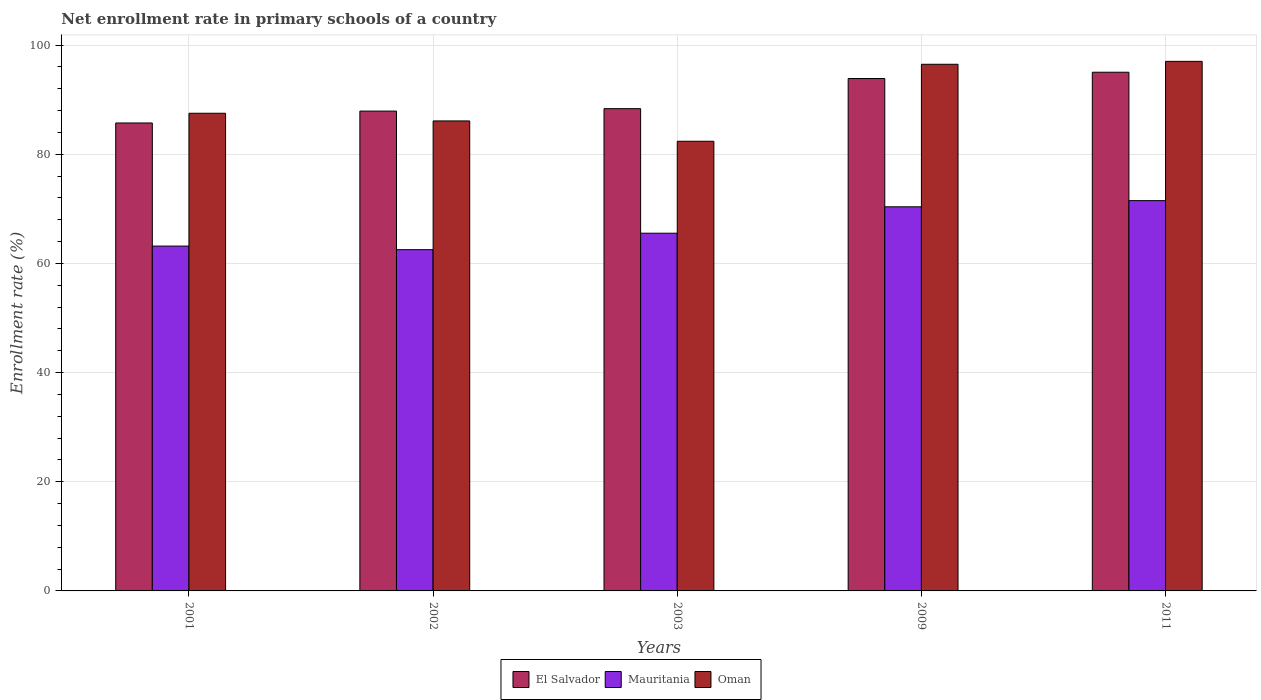How many groups of bars are there?
Your response must be concise. 5. Are the number of bars per tick equal to the number of legend labels?
Offer a very short reply. Yes. Are the number of bars on each tick of the X-axis equal?
Give a very brief answer. Yes. How many bars are there on the 1st tick from the left?
Your answer should be very brief. 3. What is the enrollment rate in primary schools in El Salvador in 2002?
Make the answer very short. 87.91. Across all years, what is the maximum enrollment rate in primary schools in Oman?
Provide a short and direct response. 97.03. Across all years, what is the minimum enrollment rate in primary schools in Mauritania?
Keep it short and to the point. 62.52. In which year was the enrollment rate in primary schools in Mauritania maximum?
Offer a terse response. 2011. What is the total enrollment rate in primary schools in El Salvador in the graph?
Keep it short and to the point. 450.93. What is the difference between the enrollment rate in primary schools in Oman in 2002 and that in 2011?
Provide a succinct answer. -10.91. What is the difference between the enrollment rate in primary schools in Mauritania in 2003 and the enrollment rate in primary schools in Oman in 2009?
Offer a very short reply. -30.95. What is the average enrollment rate in primary schools in Oman per year?
Your answer should be compact. 89.91. In the year 2002, what is the difference between the enrollment rate in primary schools in Oman and enrollment rate in primary schools in Mauritania?
Make the answer very short. 23.59. What is the ratio of the enrollment rate in primary schools in Mauritania in 2002 to that in 2003?
Keep it short and to the point. 0.95. Is the enrollment rate in primary schools in Mauritania in 2001 less than that in 2009?
Offer a terse response. Yes. What is the difference between the highest and the second highest enrollment rate in primary schools in Oman?
Offer a terse response. 0.54. What is the difference between the highest and the lowest enrollment rate in primary schools in El Salvador?
Make the answer very short. 9.3. In how many years, is the enrollment rate in primary schools in Mauritania greater than the average enrollment rate in primary schools in Mauritania taken over all years?
Your answer should be compact. 2. Is the sum of the enrollment rate in primary schools in Mauritania in 2003 and 2009 greater than the maximum enrollment rate in primary schools in El Salvador across all years?
Offer a very short reply. Yes. What does the 2nd bar from the left in 2003 represents?
Offer a very short reply. Mauritania. What does the 3rd bar from the right in 2001 represents?
Give a very brief answer. El Salvador. Is it the case that in every year, the sum of the enrollment rate in primary schools in El Salvador and enrollment rate in primary schools in Mauritania is greater than the enrollment rate in primary schools in Oman?
Make the answer very short. Yes. How many bars are there?
Make the answer very short. 15. Are all the bars in the graph horizontal?
Make the answer very short. No. Are the values on the major ticks of Y-axis written in scientific E-notation?
Your answer should be compact. No. Does the graph contain any zero values?
Offer a terse response. No. Does the graph contain grids?
Your answer should be very brief. Yes. Where does the legend appear in the graph?
Ensure brevity in your answer.  Bottom center. What is the title of the graph?
Your response must be concise. Net enrollment rate in primary schools of a country. Does "Afghanistan" appear as one of the legend labels in the graph?
Make the answer very short. No. What is the label or title of the Y-axis?
Your answer should be very brief. Enrollment rate (%). What is the Enrollment rate (%) of El Salvador in 2001?
Make the answer very short. 85.74. What is the Enrollment rate (%) of Mauritania in 2001?
Your answer should be compact. 63.18. What is the Enrollment rate (%) of Oman in 2001?
Ensure brevity in your answer.  87.52. What is the Enrollment rate (%) of El Salvador in 2002?
Provide a succinct answer. 87.91. What is the Enrollment rate (%) in Mauritania in 2002?
Provide a succinct answer. 62.52. What is the Enrollment rate (%) of Oman in 2002?
Ensure brevity in your answer.  86.11. What is the Enrollment rate (%) of El Salvador in 2003?
Ensure brevity in your answer.  88.36. What is the Enrollment rate (%) in Mauritania in 2003?
Your response must be concise. 65.54. What is the Enrollment rate (%) in Oman in 2003?
Your answer should be very brief. 82.39. What is the Enrollment rate (%) of El Salvador in 2009?
Your response must be concise. 93.88. What is the Enrollment rate (%) of Mauritania in 2009?
Keep it short and to the point. 70.38. What is the Enrollment rate (%) in Oman in 2009?
Provide a short and direct response. 96.49. What is the Enrollment rate (%) in El Salvador in 2011?
Ensure brevity in your answer.  95.03. What is the Enrollment rate (%) of Mauritania in 2011?
Your answer should be very brief. 71.51. What is the Enrollment rate (%) in Oman in 2011?
Keep it short and to the point. 97.03. Across all years, what is the maximum Enrollment rate (%) in El Salvador?
Your answer should be very brief. 95.03. Across all years, what is the maximum Enrollment rate (%) of Mauritania?
Provide a succinct answer. 71.51. Across all years, what is the maximum Enrollment rate (%) in Oman?
Provide a short and direct response. 97.03. Across all years, what is the minimum Enrollment rate (%) of El Salvador?
Your response must be concise. 85.74. Across all years, what is the minimum Enrollment rate (%) in Mauritania?
Ensure brevity in your answer.  62.52. Across all years, what is the minimum Enrollment rate (%) of Oman?
Your response must be concise. 82.39. What is the total Enrollment rate (%) of El Salvador in the graph?
Make the answer very short. 450.93. What is the total Enrollment rate (%) of Mauritania in the graph?
Keep it short and to the point. 333.14. What is the total Enrollment rate (%) in Oman in the graph?
Make the answer very short. 449.54. What is the difference between the Enrollment rate (%) in El Salvador in 2001 and that in 2002?
Offer a very short reply. -2.18. What is the difference between the Enrollment rate (%) in Mauritania in 2001 and that in 2002?
Provide a succinct answer. 0.66. What is the difference between the Enrollment rate (%) in Oman in 2001 and that in 2002?
Ensure brevity in your answer.  1.41. What is the difference between the Enrollment rate (%) in El Salvador in 2001 and that in 2003?
Provide a short and direct response. -2.62. What is the difference between the Enrollment rate (%) of Mauritania in 2001 and that in 2003?
Offer a very short reply. -2.35. What is the difference between the Enrollment rate (%) of Oman in 2001 and that in 2003?
Ensure brevity in your answer.  5.13. What is the difference between the Enrollment rate (%) in El Salvador in 2001 and that in 2009?
Keep it short and to the point. -8.14. What is the difference between the Enrollment rate (%) of Mauritania in 2001 and that in 2009?
Your response must be concise. -7.19. What is the difference between the Enrollment rate (%) in Oman in 2001 and that in 2009?
Your answer should be very brief. -8.97. What is the difference between the Enrollment rate (%) in El Salvador in 2001 and that in 2011?
Your response must be concise. -9.3. What is the difference between the Enrollment rate (%) in Mauritania in 2001 and that in 2011?
Your answer should be very brief. -8.33. What is the difference between the Enrollment rate (%) in Oman in 2001 and that in 2011?
Give a very brief answer. -9.51. What is the difference between the Enrollment rate (%) of El Salvador in 2002 and that in 2003?
Ensure brevity in your answer.  -0.44. What is the difference between the Enrollment rate (%) of Mauritania in 2002 and that in 2003?
Your answer should be compact. -3.01. What is the difference between the Enrollment rate (%) of Oman in 2002 and that in 2003?
Offer a very short reply. 3.73. What is the difference between the Enrollment rate (%) in El Salvador in 2002 and that in 2009?
Offer a very short reply. -5.97. What is the difference between the Enrollment rate (%) in Mauritania in 2002 and that in 2009?
Provide a succinct answer. -7.85. What is the difference between the Enrollment rate (%) in Oman in 2002 and that in 2009?
Ensure brevity in your answer.  -10.38. What is the difference between the Enrollment rate (%) of El Salvador in 2002 and that in 2011?
Offer a terse response. -7.12. What is the difference between the Enrollment rate (%) in Mauritania in 2002 and that in 2011?
Give a very brief answer. -8.98. What is the difference between the Enrollment rate (%) in Oman in 2002 and that in 2011?
Give a very brief answer. -10.91. What is the difference between the Enrollment rate (%) in El Salvador in 2003 and that in 2009?
Offer a very short reply. -5.52. What is the difference between the Enrollment rate (%) of Mauritania in 2003 and that in 2009?
Your answer should be compact. -4.84. What is the difference between the Enrollment rate (%) of Oman in 2003 and that in 2009?
Offer a very short reply. -14.1. What is the difference between the Enrollment rate (%) in El Salvador in 2003 and that in 2011?
Ensure brevity in your answer.  -6.68. What is the difference between the Enrollment rate (%) in Mauritania in 2003 and that in 2011?
Provide a short and direct response. -5.97. What is the difference between the Enrollment rate (%) in Oman in 2003 and that in 2011?
Offer a terse response. -14.64. What is the difference between the Enrollment rate (%) in El Salvador in 2009 and that in 2011?
Your answer should be very brief. -1.15. What is the difference between the Enrollment rate (%) in Mauritania in 2009 and that in 2011?
Give a very brief answer. -1.13. What is the difference between the Enrollment rate (%) in Oman in 2009 and that in 2011?
Make the answer very short. -0.54. What is the difference between the Enrollment rate (%) of El Salvador in 2001 and the Enrollment rate (%) of Mauritania in 2002?
Offer a very short reply. 23.21. What is the difference between the Enrollment rate (%) in El Salvador in 2001 and the Enrollment rate (%) in Oman in 2002?
Your response must be concise. -0.37. What is the difference between the Enrollment rate (%) in Mauritania in 2001 and the Enrollment rate (%) in Oman in 2002?
Make the answer very short. -22.93. What is the difference between the Enrollment rate (%) in El Salvador in 2001 and the Enrollment rate (%) in Mauritania in 2003?
Provide a short and direct response. 20.2. What is the difference between the Enrollment rate (%) of El Salvador in 2001 and the Enrollment rate (%) of Oman in 2003?
Your response must be concise. 3.35. What is the difference between the Enrollment rate (%) in Mauritania in 2001 and the Enrollment rate (%) in Oman in 2003?
Your response must be concise. -19.2. What is the difference between the Enrollment rate (%) of El Salvador in 2001 and the Enrollment rate (%) of Mauritania in 2009?
Make the answer very short. 15.36. What is the difference between the Enrollment rate (%) of El Salvador in 2001 and the Enrollment rate (%) of Oman in 2009?
Keep it short and to the point. -10.75. What is the difference between the Enrollment rate (%) in Mauritania in 2001 and the Enrollment rate (%) in Oman in 2009?
Provide a succinct answer. -33.31. What is the difference between the Enrollment rate (%) in El Salvador in 2001 and the Enrollment rate (%) in Mauritania in 2011?
Give a very brief answer. 14.23. What is the difference between the Enrollment rate (%) of El Salvador in 2001 and the Enrollment rate (%) of Oman in 2011?
Offer a very short reply. -11.29. What is the difference between the Enrollment rate (%) in Mauritania in 2001 and the Enrollment rate (%) in Oman in 2011?
Your answer should be very brief. -33.84. What is the difference between the Enrollment rate (%) of El Salvador in 2002 and the Enrollment rate (%) of Mauritania in 2003?
Your response must be concise. 22.38. What is the difference between the Enrollment rate (%) in El Salvador in 2002 and the Enrollment rate (%) in Oman in 2003?
Provide a short and direct response. 5.53. What is the difference between the Enrollment rate (%) in Mauritania in 2002 and the Enrollment rate (%) in Oman in 2003?
Ensure brevity in your answer.  -19.86. What is the difference between the Enrollment rate (%) of El Salvador in 2002 and the Enrollment rate (%) of Mauritania in 2009?
Your answer should be very brief. 17.54. What is the difference between the Enrollment rate (%) in El Salvador in 2002 and the Enrollment rate (%) in Oman in 2009?
Your answer should be very brief. -8.58. What is the difference between the Enrollment rate (%) in Mauritania in 2002 and the Enrollment rate (%) in Oman in 2009?
Keep it short and to the point. -33.97. What is the difference between the Enrollment rate (%) of El Salvador in 2002 and the Enrollment rate (%) of Mauritania in 2011?
Make the answer very short. 16.4. What is the difference between the Enrollment rate (%) of El Salvador in 2002 and the Enrollment rate (%) of Oman in 2011?
Keep it short and to the point. -9.11. What is the difference between the Enrollment rate (%) in Mauritania in 2002 and the Enrollment rate (%) in Oman in 2011?
Provide a succinct answer. -34.5. What is the difference between the Enrollment rate (%) in El Salvador in 2003 and the Enrollment rate (%) in Mauritania in 2009?
Make the answer very short. 17.98. What is the difference between the Enrollment rate (%) in El Salvador in 2003 and the Enrollment rate (%) in Oman in 2009?
Your response must be concise. -8.13. What is the difference between the Enrollment rate (%) of Mauritania in 2003 and the Enrollment rate (%) of Oman in 2009?
Offer a terse response. -30.95. What is the difference between the Enrollment rate (%) of El Salvador in 2003 and the Enrollment rate (%) of Mauritania in 2011?
Offer a terse response. 16.85. What is the difference between the Enrollment rate (%) in El Salvador in 2003 and the Enrollment rate (%) in Oman in 2011?
Make the answer very short. -8.67. What is the difference between the Enrollment rate (%) in Mauritania in 2003 and the Enrollment rate (%) in Oman in 2011?
Provide a short and direct response. -31.49. What is the difference between the Enrollment rate (%) of El Salvador in 2009 and the Enrollment rate (%) of Mauritania in 2011?
Provide a succinct answer. 22.37. What is the difference between the Enrollment rate (%) in El Salvador in 2009 and the Enrollment rate (%) in Oman in 2011?
Keep it short and to the point. -3.15. What is the difference between the Enrollment rate (%) of Mauritania in 2009 and the Enrollment rate (%) of Oman in 2011?
Your answer should be compact. -26.65. What is the average Enrollment rate (%) in El Salvador per year?
Keep it short and to the point. 90.19. What is the average Enrollment rate (%) in Mauritania per year?
Give a very brief answer. 66.63. What is the average Enrollment rate (%) of Oman per year?
Your answer should be very brief. 89.91. In the year 2001, what is the difference between the Enrollment rate (%) in El Salvador and Enrollment rate (%) in Mauritania?
Your response must be concise. 22.55. In the year 2001, what is the difference between the Enrollment rate (%) in El Salvador and Enrollment rate (%) in Oman?
Make the answer very short. -1.78. In the year 2001, what is the difference between the Enrollment rate (%) of Mauritania and Enrollment rate (%) of Oman?
Your answer should be compact. -24.33. In the year 2002, what is the difference between the Enrollment rate (%) of El Salvador and Enrollment rate (%) of Mauritania?
Keep it short and to the point. 25.39. In the year 2002, what is the difference between the Enrollment rate (%) of El Salvador and Enrollment rate (%) of Oman?
Provide a succinct answer. 1.8. In the year 2002, what is the difference between the Enrollment rate (%) in Mauritania and Enrollment rate (%) in Oman?
Make the answer very short. -23.59. In the year 2003, what is the difference between the Enrollment rate (%) in El Salvador and Enrollment rate (%) in Mauritania?
Your response must be concise. 22.82. In the year 2003, what is the difference between the Enrollment rate (%) in El Salvador and Enrollment rate (%) in Oman?
Offer a terse response. 5.97. In the year 2003, what is the difference between the Enrollment rate (%) in Mauritania and Enrollment rate (%) in Oman?
Offer a terse response. -16.85. In the year 2009, what is the difference between the Enrollment rate (%) of El Salvador and Enrollment rate (%) of Mauritania?
Keep it short and to the point. 23.5. In the year 2009, what is the difference between the Enrollment rate (%) in El Salvador and Enrollment rate (%) in Oman?
Ensure brevity in your answer.  -2.61. In the year 2009, what is the difference between the Enrollment rate (%) of Mauritania and Enrollment rate (%) of Oman?
Make the answer very short. -26.11. In the year 2011, what is the difference between the Enrollment rate (%) of El Salvador and Enrollment rate (%) of Mauritania?
Make the answer very short. 23.52. In the year 2011, what is the difference between the Enrollment rate (%) of El Salvador and Enrollment rate (%) of Oman?
Ensure brevity in your answer.  -1.99. In the year 2011, what is the difference between the Enrollment rate (%) of Mauritania and Enrollment rate (%) of Oman?
Your response must be concise. -25.52. What is the ratio of the Enrollment rate (%) of El Salvador in 2001 to that in 2002?
Keep it short and to the point. 0.98. What is the ratio of the Enrollment rate (%) of Mauritania in 2001 to that in 2002?
Your answer should be compact. 1.01. What is the ratio of the Enrollment rate (%) in Oman in 2001 to that in 2002?
Give a very brief answer. 1.02. What is the ratio of the Enrollment rate (%) in El Salvador in 2001 to that in 2003?
Your answer should be very brief. 0.97. What is the ratio of the Enrollment rate (%) in Mauritania in 2001 to that in 2003?
Make the answer very short. 0.96. What is the ratio of the Enrollment rate (%) of Oman in 2001 to that in 2003?
Make the answer very short. 1.06. What is the ratio of the Enrollment rate (%) of El Salvador in 2001 to that in 2009?
Give a very brief answer. 0.91. What is the ratio of the Enrollment rate (%) in Mauritania in 2001 to that in 2009?
Make the answer very short. 0.9. What is the ratio of the Enrollment rate (%) in Oman in 2001 to that in 2009?
Ensure brevity in your answer.  0.91. What is the ratio of the Enrollment rate (%) in El Salvador in 2001 to that in 2011?
Keep it short and to the point. 0.9. What is the ratio of the Enrollment rate (%) of Mauritania in 2001 to that in 2011?
Your answer should be compact. 0.88. What is the ratio of the Enrollment rate (%) of Oman in 2001 to that in 2011?
Your response must be concise. 0.9. What is the ratio of the Enrollment rate (%) of Mauritania in 2002 to that in 2003?
Keep it short and to the point. 0.95. What is the ratio of the Enrollment rate (%) in Oman in 2002 to that in 2003?
Your answer should be compact. 1.05. What is the ratio of the Enrollment rate (%) of El Salvador in 2002 to that in 2009?
Give a very brief answer. 0.94. What is the ratio of the Enrollment rate (%) in Mauritania in 2002 to that in 2009?
Provide a succinct answer. 0.89. What is the ratio of the Enrollment rate (%) of Oman in 2002 to that in 2009?
Ensure brevity in your answer.  0.89. What is the ratio of the Enrollment rate (%) of El Salvador in 2002 to that in 2011?
Offer a terse response. 0.93. What is the ratio of the Enrollment rate (%) in Mauritania in 2002 to that in 2011?
Ensure brevity in your answer.  0.87. What is the ratio of the Enrollment rate (%) in Oman in 2002 to that in 2011?
Provide a succinct answer. 0.89. What is the ratio of the Enrollment rate (%) in Mauritania in 2003 to that in 2009?
Your answer should be compact. 0.93. What is the ratio of the Enrollment rate (%) in Oman in 2003 to that in 2009?
Your response must be concise. 0.85. What is the ratio of the Enrollment rate (%) in El Salvador in 2003 to that in 2011?
Keep it short and to the point. 0.93. What is the ratio of the Enrollment rate (%) in Mauritania in 2003 to that in 2011?
Ensure brevity in your answer.  0.92. What is the ratio of the Enrollment rate (%) of Oman in 2003 to that in 2011?
Provide a short and direct response. 0.85. What is the ratio of the Enrollment rate (%) in El Salvador in 2009 to that in 2011?
Your answer should be very brief. 0.99. What is the ratio of the Enrollment rate (%) of Mauritania in 2009 to that in 2011?
Your answer should be very brief. 0.98. What is the ratio of the Enrollment rate (%) of Oman in 2009 to that in 2011?
Your response must be concise. 0.99. What is the difference between the highest and the second highest Enrollment rate (%) in El Salvador?
Provide a short and direct response. 1.15. What is the difference between the highest and the second highest Enrollment rate (%) in Mauritania?
Your answer should be compact. 1.13. What is the difference between the highest and the second highest Enrollment rate (%) in Oman?
Offer a terse response. 0.54. What is the difference between the highest and the lowest Enrollment rate (%) of El Salvador?
Give a very brief answer. 9.3. What is the difference between the highest and the lowest Enrollment rate (%) in Mauritania?
Your answer should be compact. 8.98. What is the difference between the highest and the lowest Enrollment rate (%) of Oman?
Keep it short and to the point. 14.64. 